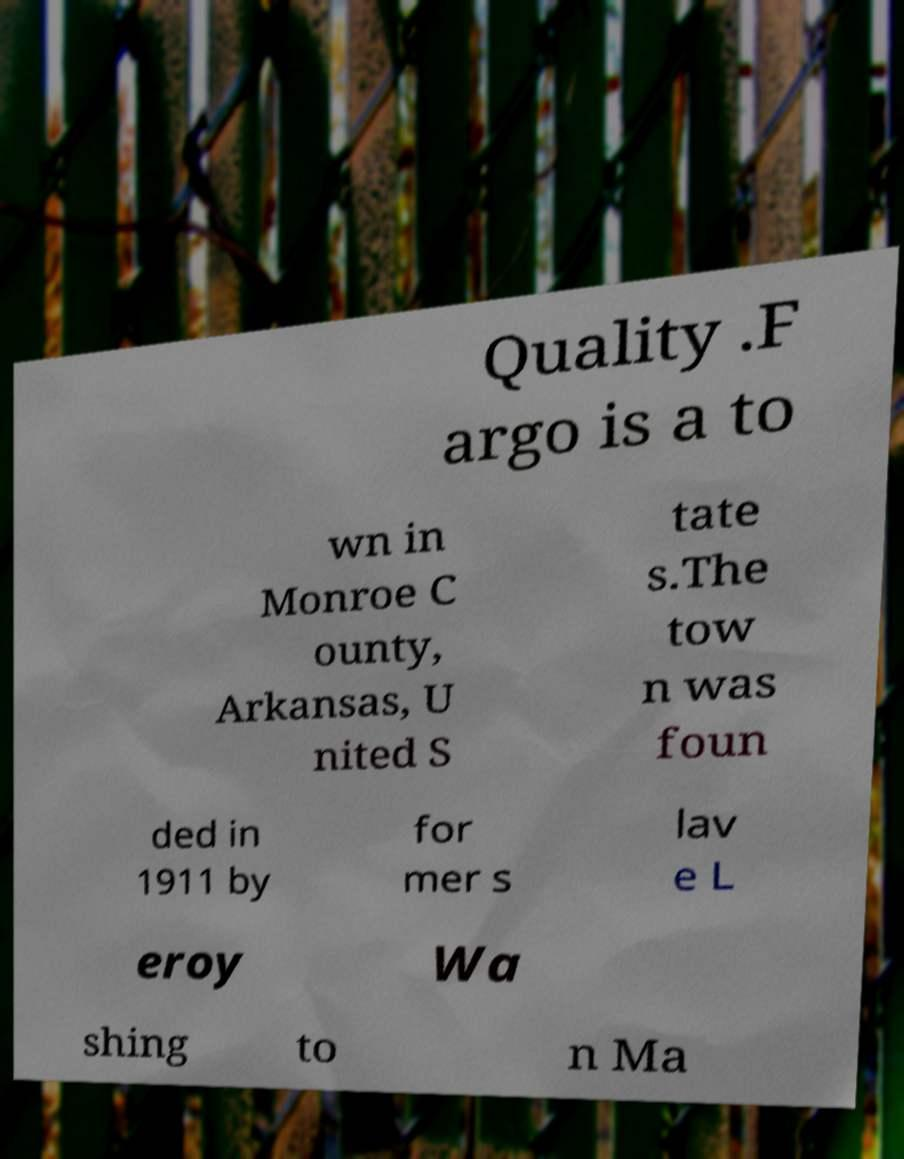Could you assist in decoding the text presented in this image and type it out clearly? Quality .F argo is a to wn in Monroe C ounty, Arkansas, U nited S tate s.The tow n was foun ded in 1911 by for mer s lav e L eroy Wa shing to n Ma 